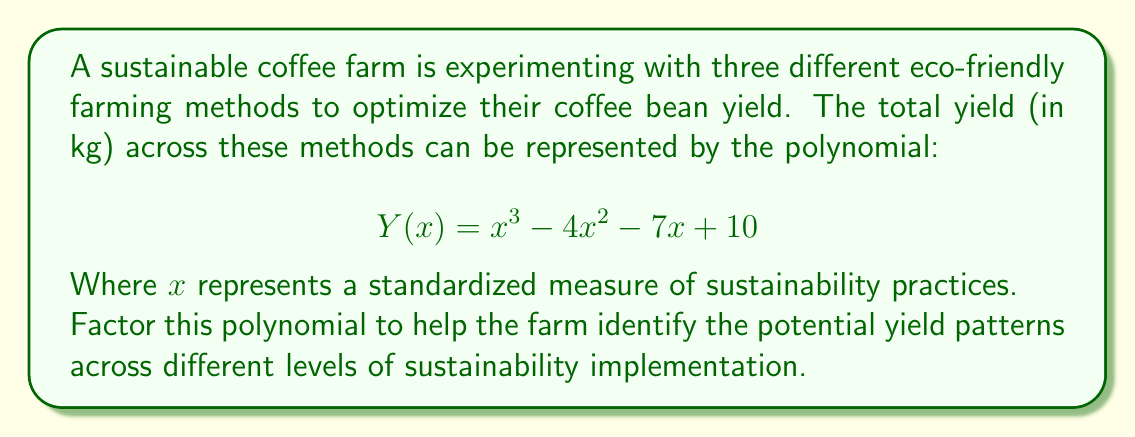Show me your answer to this math problem. To factor this polynomial, we'll follow these steps:

1) First, let's check if there are any common factors. There are none, so we proceed.

2) This is a cubic polynomial. One approach is to guess one root and then use polynomial long division to reduce it to a quadratic.

3) Let's try some potential rational roots: ±1, ±2, ±5, ±10 (factors of the constant term)

4) Testing these, we find that x = 5 is a root. So (x - 5) is a factor.

5) Let's use polynomial long division:

$$ \frac{x^3 - 4x^2 - 7x + 10}{x - 5} $$

   $x^3 - 5x^2$
   $\underline{5x^2 - 7x}$
   $5x^2 - 25x$
   $\underline{18x + 10}$
   $18x - 90$
   $\underline{100}$

6) The result of the division is $x^2 + x - 2$, with no remainder.

7) So now we have: $Y(x) = (x - 5)(x^2 + x - 2)$

8) We can factor the quadratic term further:
   $x^2 + x - 2 = (x + 2)(x - 1)$

9) Therefore, the fully factored polynomial is:

$$ Y(x) = (x - 5)(x + 2)(x - 1) $$

This factorization reveals the roots of the polynomial, which represent the points where the yield would be zero according to this model.
Answer: $$ Y(x) = (x - 5)(x + 2)(x - 1) $$ 